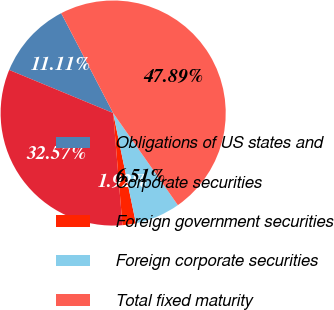Convert chart to OTSL. <chart><loc_0><loc_0><loc_500><loc_500><pie_chart><fcel>Obligations of US states and<fcel>Corporate securities<fcel>Foreign government securities<fcel>Foreign corporate securities<fcel>Total fixed maturity<nl><fcel>11.11%<fcel>32.57%<fcel>1.92%<fcel>6.51%<fcel>47.89%<nl></chart> 